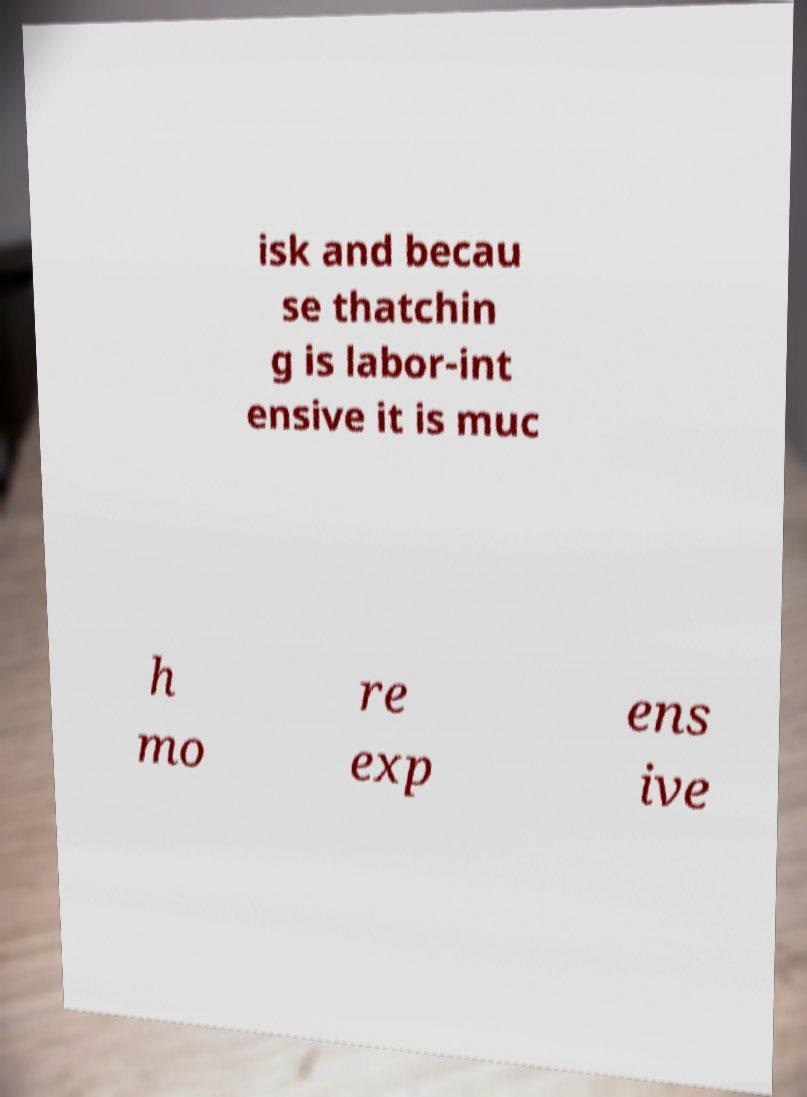Please identify and transcribe the text found in this image. isk and becau se thatchin g is labor-int ensive it is muc h mo re exp ens ive 